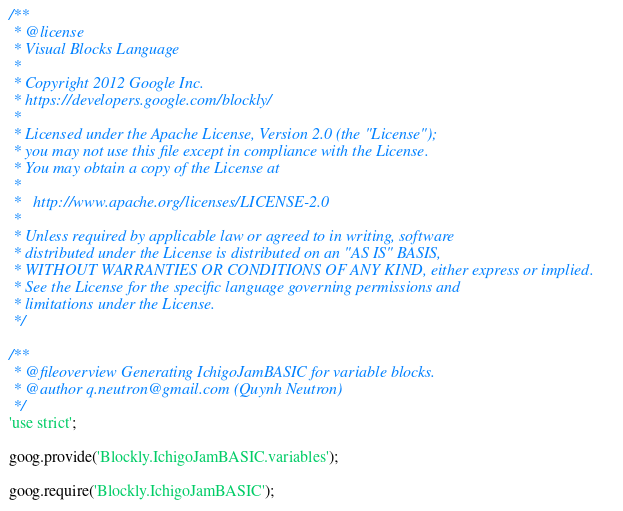<code> <loc_0><loc_0><loc_500><loc_500><_JavaScript_>/**
 * @license
 * Visual Blocks Language
 *
 * Copyright 2012 Google Inc.
 * https://developers.google.com/blockly/
 *
 * Licensed under the Apache License, Version 2.0 (the "License");
 * you may not use this file except in compliance with the License.
 * You may obtain a copy of the License at
 *
 *   http://www.apache.org/licenses/LICENSE-2.0
 *
 * Unless required by applicable law or agreed to in writing, software
 * distributed under the License is distributed on an "AS IS" BASIS,
 * WITHOUT WARRANTIES OR CONDITIONS OF ANY KIND, either express or implied.
 * See the License for the specific language governing permissions and
 * limitations under the License.
 */

/**
 * @fileoverview Generating IchigoJamBASIC for variable blocks.
 * @author q.neutron@gmail.com (Quynh Neutron)
 */
'use strict';

goog.provide('Blockly.IchigoJamBASIC.variables');

goog.require('Blockly.IchigoJamBASIC');

</code> 